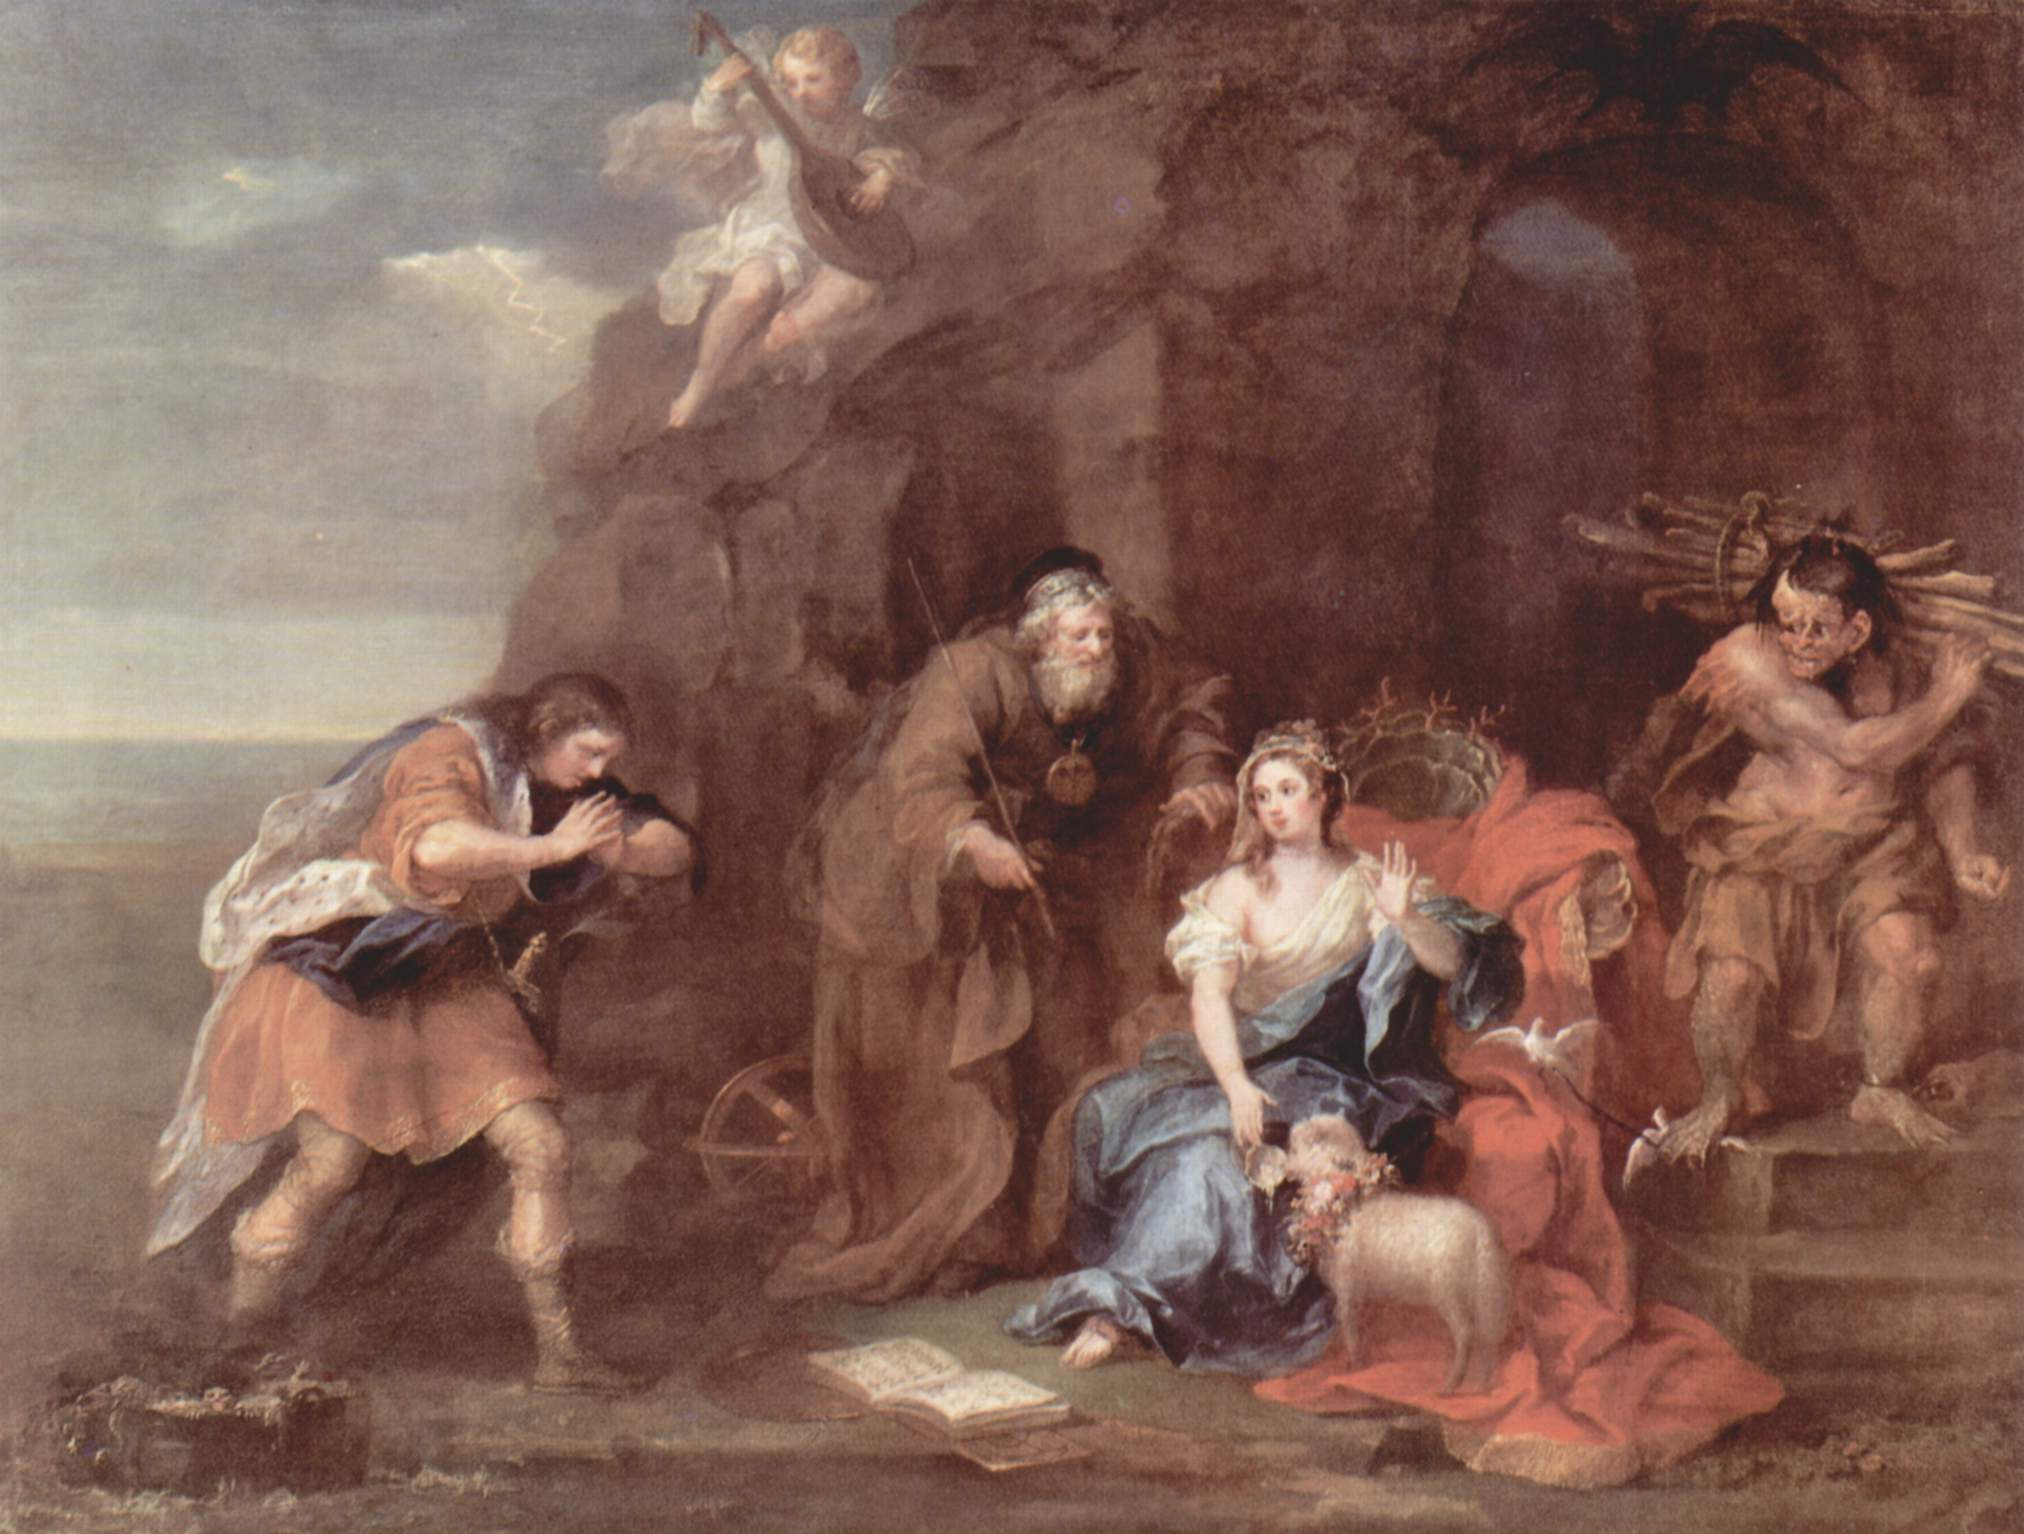Imagine this painting had an auditory element. What sounds would you associate with it? If this painting had an auditory element, the soundscape would be a rich blend of harmonious melodies and ambient noises that enhance its narrative depth. The gentle strumming of a lute or soft flute notes would dominate, reflecting the figure playing the instrument. This calming music would intermingle with the serene murmurs of a distant stream or the rustling leaves, suggesting a connection to nature despite the cave-like setting.

In the background, one could also hear the faint sound of pages turning, corresponding with the woman's engagement with her book, complemented by her occasional soft sighs or murmurs of contemplation. Conversations in hushed tones between the figures add a layer of intimacy and humanity to the scene.

The cherubs might bring an ethereal chime or whispered laughter, adding a touch of celestial magic. The occasional crackle of wood or the thud of footsteps would mark the rugged figure's movements, reminding viewers of the hard labor and life's burdens, yet all these sounds blend seamlessly into a unified, harmonious auditory experience. 